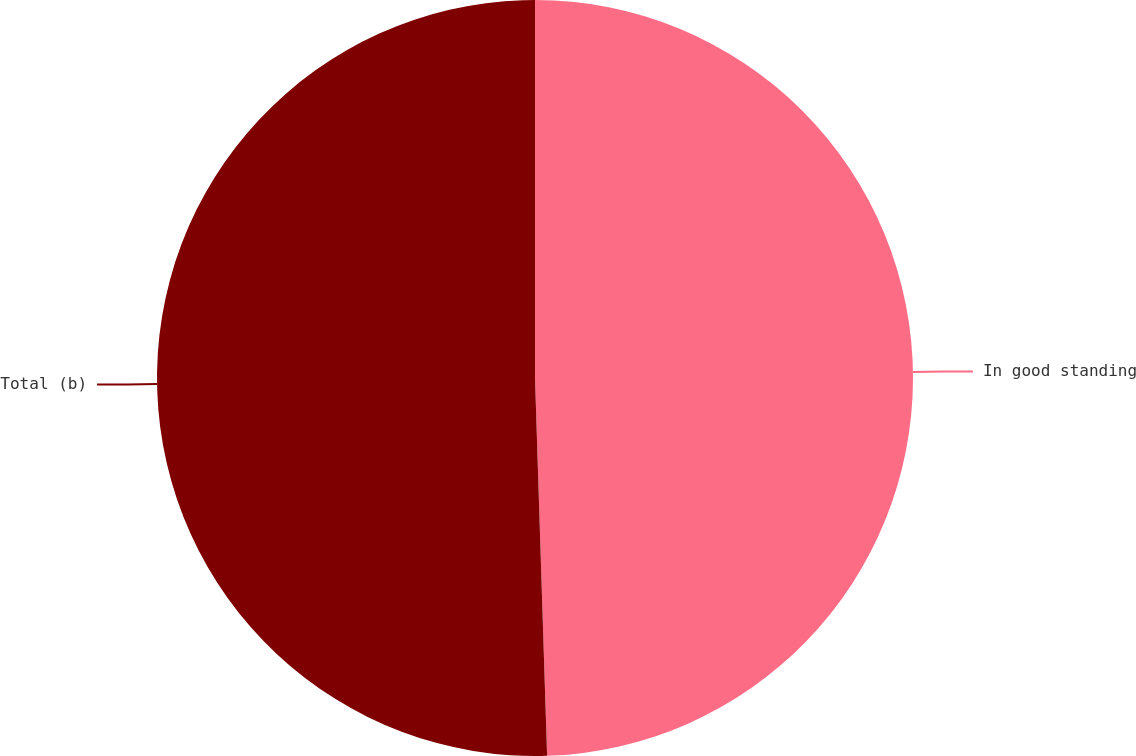<chart> <loc_0><loc_0><loc_500><loc_500><pie_chart><fcel>In good standing<fcel>Total (b)<nl><fcel>49.49%<fcel>50.51%<nl></chart> 